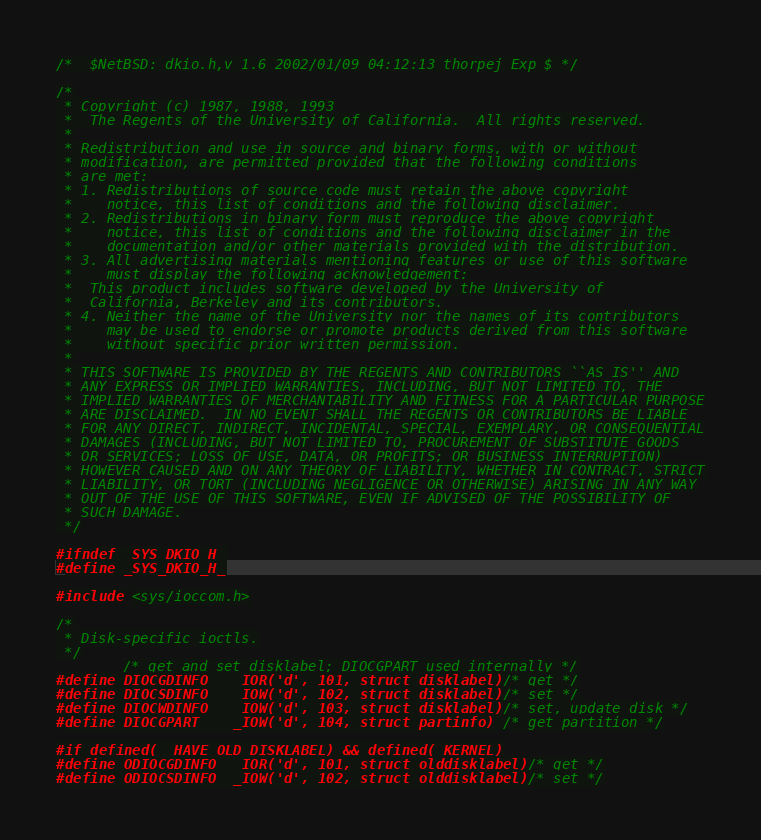<code> <loc_0><loc_0><loc_500><loc_500><_C_>/*	$NetBSD: dkio.h,v 1.6 2002/01/09 04:12:13 thorpej Exp $	*/

/*
 * Copyright (c) 1987, 1988, 1993
 *	The Regents of the University of California.  All rights reserved.
 *
 * Redistribution and use in source and binary forms, with or without
 * modification, are permitted provided that the following conditions
 * are met:
 * 1. Redistributions of source code must retain the above copyright
 *    notice, this list of conditions and the following disclaimer.
 * 2. Redistributions in binary form must reproduce the above copyright
 *    notice, this list of conditions and the following disclaimer in the
 *    documentation and/or other materials provided with the distribution.
 * 3. All advertising materials mentioning features or use of this software
 *    must display the following acknowledgement:
 *	This product includes software developed by the University of
 *	California, Berkeley and its contributors.
 * 4. Neither the name of the University nor the names of its contributors
 *    may be used to endorse or promote products derived from this software
 *    without specific prior written permission.
 *
 * THIS SOFTWARE IS PROVIDED BY THE REGENTS AND CONTRIBUTORS ``AS IS'' AND
 * ANY EXPRESS OR IMPLIED WARRANTIES, INCLUDING, BUT NOT LIMITED TO, THE
 * IMPLIED WARRANTIES OF MERCHANTABILITY AND FITNESS FOR A PARTICULAR PURPOSE
 * ARE DISCLAIMED.  IN NO EVENT SHALL THE REGENTS OR CONTRIBUTORS BE LIABLE
 * FOR ANY DIRECT, INDIRECT, INCIDENTAL, SPECIAL, EXEMPLARY, OR CONSEQUENTIAL
 * DAMAGES (INCLUDING, BUT NOT LIMITED TO, PROCUREMENT OF SUBSTITUTE GOODS
 * OR SERVICES; LOSS OF USE, DATA, OR PROFITS; OR BUSINESS INTERRUPTION)
 * HOWEVER CAUSED AND ON ANY THEORY OF LIABILITY, WHETHER IN CONTRACT, STRICT
 * LIABILITY, OR TORT (INCLUDING NEGLIGENCE OR OTHERWISE) ARISING IN ANY WAY
 * OUT OF THE USE OF THIS SOFTWARE, EVEN IF ADVISED OF THE POSSIBILITY OF
 * SUCH DAMAGE.
 */

#ifndef _SYS_DKIO_H_
#define _SYS_DKIO_H_

#include <sys/ioccom.h>

/*
 * Disk-specific ioctls.
 */
		/* get and set disklabel; DIOCGPART used internally */
#define DIOCGDINFO	_IOR('d', 101, struct disklabel)/* get */
#define DIOCSDINFO	_IOW('d', 102, struct disklabel)/* set */
#define DIOCWDINFO	_IOW('d', 103, struct disklabel)/* set, update disk */
#define DIOCGPART	_IOW('d', 104, struct partinfo)	/* get partition */

#if defined(__HAVE_OLD_DISKLABEL) && defined(_KERNEL)
#define ODIOCGDINFO	_IOR('d', 101, struct olddisklabel)/* get */
#define ODIOCSDINFO	_IOW('d', 102, struct olddisklabel)/* set */</code> 